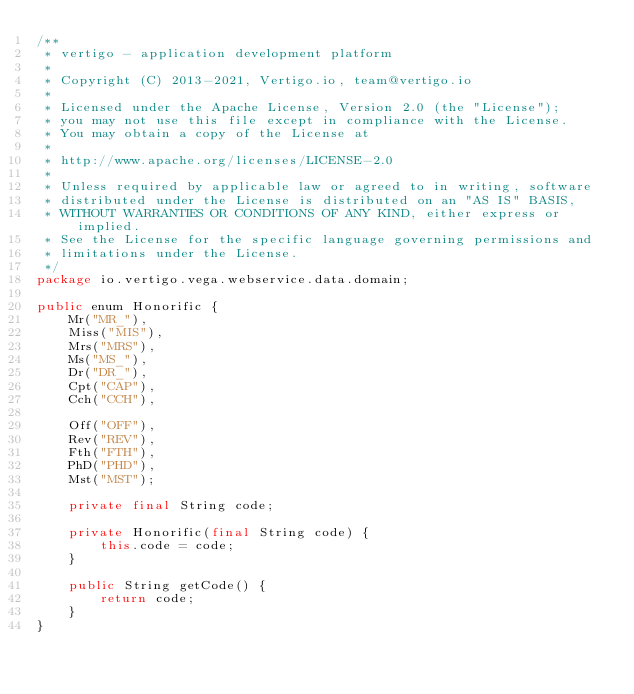Convert code to text. <code><loc_0><loc_0><loc_500><loc_500><_Java_>/**
 * vertigo - application development platform
 *
 * Copyright (C) 2013-2021, Vertigo.io, team@vertigo.io
 *
 * Licensed under the Apache License, Version 2.0 (the "License");
 * you may not use this file except in compliance with the License.
 * You may obtain a copy of the License at
 *
 * http://www.apache.org/licenses/LICENSE-2.0
 *
 * Unless required by applicable law or agreed to in writing, software
 * distributed under the License is distributed on an "AS IS" BASIS,
 * WITHOUT WARRANTIES OR CONDITIONS OF ANY KIND, either express or implied.
 * See the License for the specific language governing permissions and
 * limitations under the License.
 */
package io.vertigo.vega.webservice.data.domain;

public enum Honorific {
	Mr("MR_"),
	Miss("MIS"),
	Mrs("MRS"),
	Ms("MS_"),
	Dr("DR_"),
	Cpt("CAP"),
	Cch("CCH"),

	Off("OFF"),
	Rev("REV"),
	Fth("FTH"),
	PhD("PHD"),
	Mst("MST");

	private final String code;

	private Honorific(final String code) {
		this.code = code;
	}

	public String getCode() {
		return code;
	}
}
</code> 